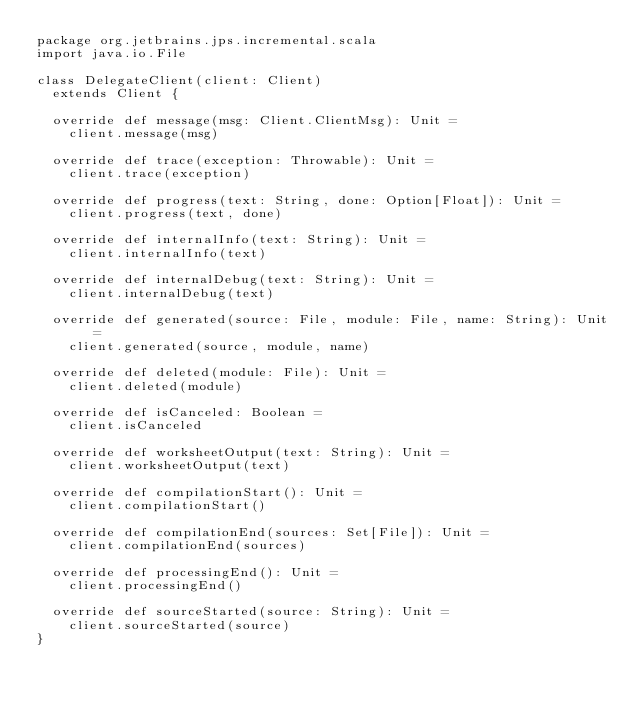Convert code to text. <code><loc_0><loc_0><loc_500><loc_500><_Scala_>package org.jetbrains.jps.incremental.scala
import java.io.File

class DelegateClient(client: Client)
  extends Client {

  override def message(msg: Client.ClientMsg): Unit =
    client.message(msg)

  override def trace(exception: Throwable): Unit =
    client.trace(exception)

  override def progress(text: String, done: Option[Float]): Unit =
    client.progress(text, done)

  override def internalInfo(text: String): Unit =
    client.internalInfo(text)

  override def internalDebug(text: String): Unit =
    client.internalDebug(text)

  override def generated(source: File, module: File, name: String): Unit =
    client.generated(source, module, name)

  override def deleted(module: File): Unit =
    client.deleted(module)

  override def isCanceled: Boolean =
    client.isCanceled

  override def worksheetOutput(text: String): Unit =
    client.worksheetOutput(text)

  override def compilationStart(): Unit =
    client.compilationStart()
  
  override def compilationEnd(sources: Set[File]): Unit =
    client.compilationEnd(sources)

  override def processingEnd(): Unit =
    client.processingEnd()

  override def sourceStarted(source: String): Unit =
    client.sourceStarted(source)
}
</code> 